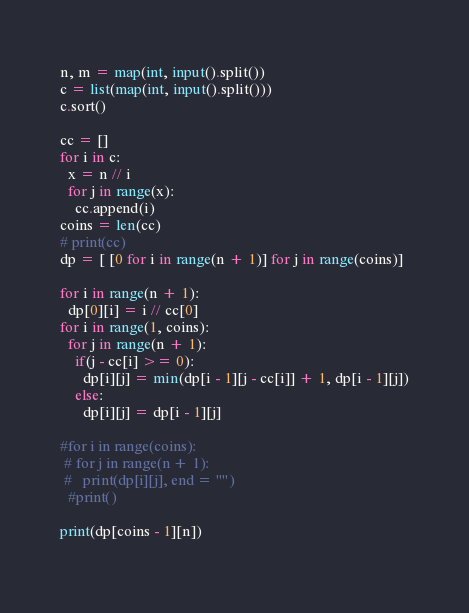Convert code to text. <code><loc_0><loc_0><loc_500><loc_500><_Python_>n, m = map(int, input().split())
c = list(map(int, input().split()))
c.sort()

cc = []
for i in c:
  x = n // i
  for j in range(x):
    cc.append(i)
coins = len(cc)
# print(cc)
dp = [ [0 for i in range(n + 1)] for j in range(coins)]

for i in range(n + 1):
  dp[0][i] = i // cc[0]
for i in range(1, coins):
  for j in range(n + 1):
    if(j - cc[i] >= 0):
      dp[i][j] = min(dp[i - 1][j - cc[i]] + 1, dp[i - 1][j])
    else:
      dp[i][j] = dp[i - 1][j]
      
#for i in range(coins):
 # for j in range(n + 1):
 #   print(dp[i][j], end = "")
  #print()
      
print(dp[coins - 1][n])
    
</code> 